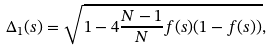Convert formula to latex. <formula><loc_0><loc_0><loc_500><loc_500>\Delta _ { 1 } ( s ) = \sqrt { 1 - 4 \frac { N - 1 } { N } f ( s ) ( 1 - f ( s ) ) } ,</formula> 